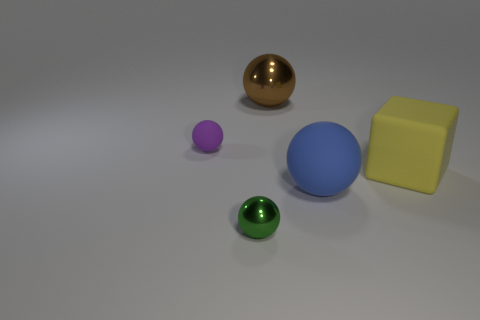Are there more blue objects that are in front of the big blue sphere than metallic spheres left of the yellow matte block?
Your response must be concise. No. Is there a blue rubber thing that has the same shape as the purple matte object?
Offer a very short reply. Yes. There is a matte ball to the left of the green shiny thing; is it the same size as the big brown object?
Offer a very short reply. No. Are there any blue metallic balls?
Keep it short and to the point. No. How many things are either tiny green metal objects to the left of the big rubber sphere or big gray matte objects?
Ensure brevity in your answer.  1. There is a tiny rubber ball; does it have the same color as the shiny object that is behind the small purple sphere?
Offer a terse response. No. Is there another blue object of the same size as the blue rubber object?
Keep it short and to the point. No. There is a small sphere that is behind the small ball that is in front of the small purple ball; what is its material?
Make the answer very short. Rubber. What number of balls have the same color as the big cube?
Offer a terse response. 0. There is a big thing that is made of the same material as the yellow block; what shape is it?
Ensure brevity in your answer.  Sphere. 